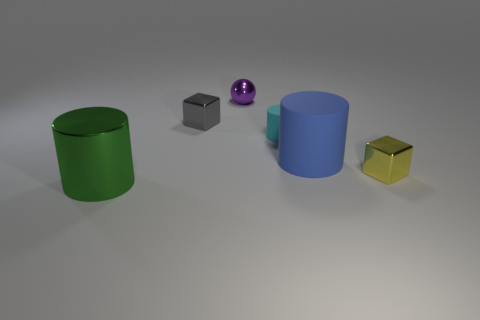How many green shiny things have the same size as the green metallic cylinder?
Ensure brevity in your answer.  0. Is the number of shiny cubes to the left of the large blue cylinder less than the number of big cylinders?
Offer a very short reply. Yes. There is a small yellow shiny block; how many big blue rubber things are in front of it?
Your answer should be very brief. 0. What is the size of the object that is to the left of the metallic cube that is to the left of the tiny shiny thing that is right of the cyan matte object?
Your answer should be compact. Large. Is the shape of the green thing the same as the tiny shiny thing on the right side of the ball?
Ensure brevity in your answer.  No. The other cylinder that is made of the same material as the small cylinder is what size?
Make the answer very short. Large. Is there any other thing that has the same color as the small rubber cylinder?
Make the answer very short. No. What is the material of the tiny cylinder that is behind the big object behind the shiny cube that is in front of the gray block?
Your answer should be very brief. Rubber. What number of rubber objects are tiny things or red objects?
Offer a very short reply. 1. How many objects are either gray shiny cylinders or metallic blocks to the left of the purple shiny sphere?
Keep it short and to the point. 1. 